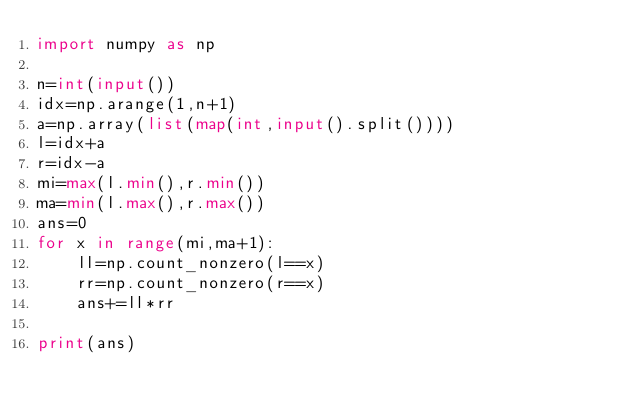Convert code to text. <code><loc_0><loc_0><loc_500><loc_500><_Python_>import numpy as np

n=int(input())
idx=np.arange(1,n+1)
a=np.array(list(map(int,input().split())))
l=idx+a
r=idx-a
mi=max(l.min(),r.min())
ma=min(l.max(),r.max())
ans=0
for x in range(mi,ma+1):
    ll=np.count_nonzero(l==x)
    rr=np.count_nonzero(r==x)
    ans+=ll*rr
    
print(ans)</code> 